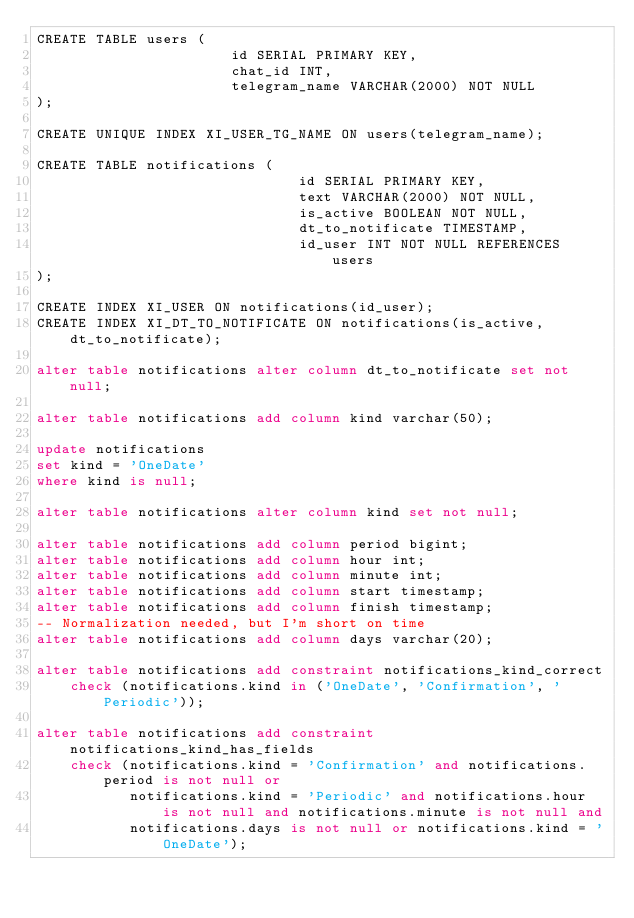Convert code to text. <code><loc_0><loc_0><loc_500><loc_500><_SQL_>CREATE TABLE users (
                       id SERIAL PRIMARY KEY,
                       chat_id INT,
                       telegram_name VARCHAR(2000) NOT NULL
);

CREATE UNIQUE INDEX XI_USER_TG_NAME ON users(telegram_name);

CREATE TABLE notifications (
                               id SERIAL PRIMARY KEY,
                               text VARCHAR(2000) NOT NULL,
                               is_active BOOLEAN NOT NULL,
                               dt_to_notificate TIMESTAMP,
                               id_user INT NOT NULL REFERENCES users
);

CREATE INDEX XI_USER ON notifications(id_user);
CREATE INDEX XI_DT_TO_NOTIFICATE ON notifications(is_active, dt_to_notificate);

alter table notifications alter column dt_to_notificate set not null;

alter table notifications add column kind varchar(50);

update notifications
set kind = 'OneDate'
where kind is null;

alter table notifications alter column kind set not null;

alter table notifications add column period bigint;
alter table notifications add column hour int;
alter table notifications add column minute int;
alter table notifications add column start timestamp;
alter table notifications add column finish timestamp;
-- Normalization needed, but I'm short on time
alter table notifications add column days varchar(20);

alter table notifications add constraint notifications_kind_correct
    check (notifications.kind in ('OneDate', 'Confirmation', 'Periodic'));

alter table notifications add constraint notifications_kind_has_fields
    check (notifications.kind = 'Confirmation' and notifications.period is not null or
           notifications.kind = 'Periodic' and notifications.hour is not null and notifications.minute is not null and
           notifications.days is not null or notifications.kind = 'OneDate');
</code> 